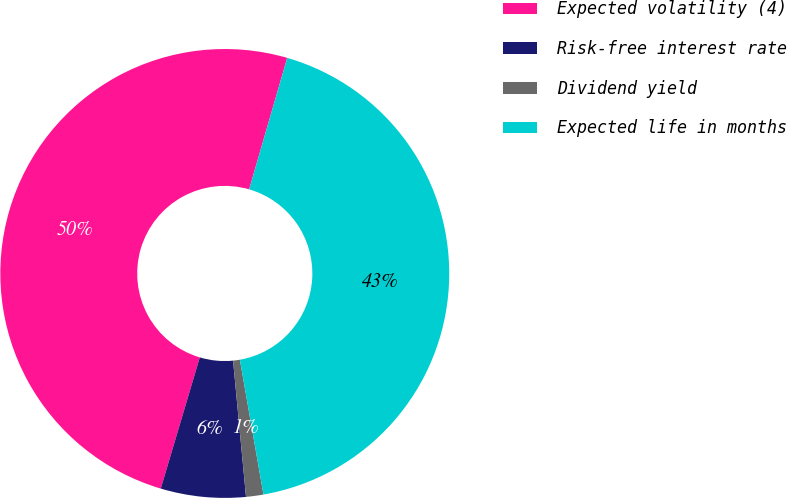Convert chart. <chart><loc_0><loc_0><loc_500><loc_500><pie_chart><fcel>Expected volatility (4)<fcel>Risk-free interest rate<fcel>Dividend yield<fcel>Expected life in months<nl><fcel>49.88%<fcel>6.11%<fcel>1.25%<fcel>42.75%<nl></chart> 